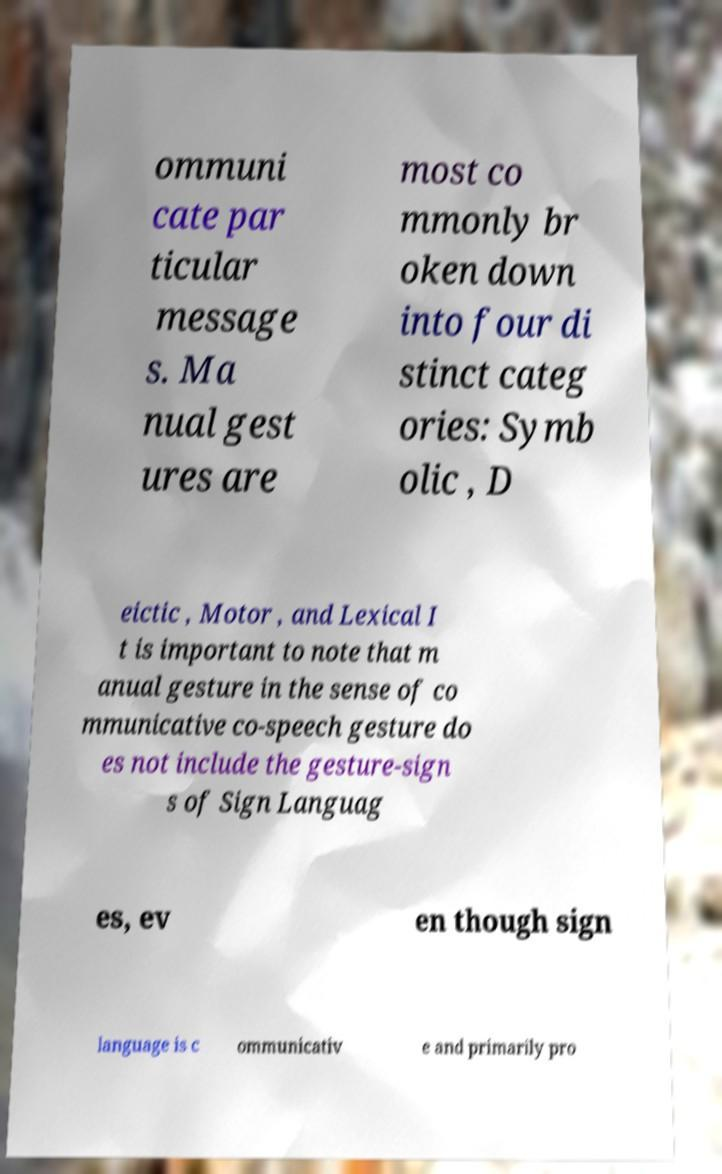Could you extract and type out the text from this image? ommuni cate par ticular message s. Ma nual gest ures are most co mmonly br oken down into four di stinct categ ories: Symb olic , D eictic , Motor , and Lexical I t is important to note that m anual gesture in the sense of co mmunicative co-speech gesture do es not include the gesture-sign s of Sign Languag es, ev en though sign language is c ommunicativ e and primarily pro 